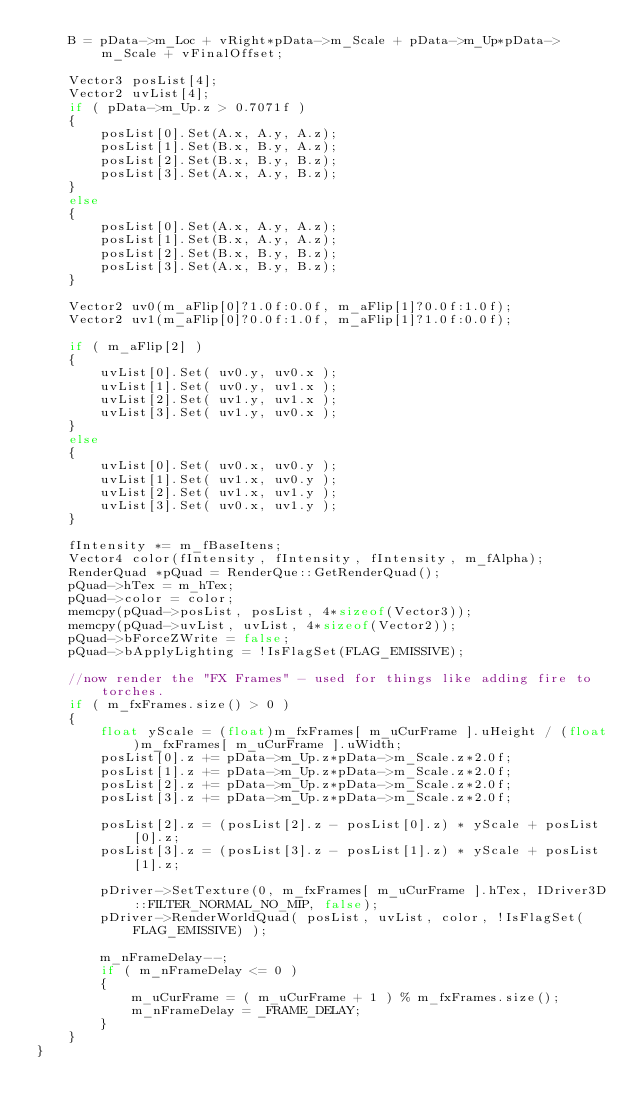Convert code to text. <code><loc_0><loc_0><loc_500><loc_500><_C++_>    B = pData->m_Loc + vRight*pData->m_Scale + pData->m_Up*pData->m_Scale + vFinalOffset;

    Vector3 posList[4];
    Vector2 uvList[4];
    if ( pData->m_Up.z > 0.7071f )
    {
        posList[0].Set(A.x, A.y, A.z);
        posList[1].Set(B.x, B.y, A.z);
        posList[2].Set(B.x, B.y, B.z);
        posList[3].Set(A.x, A.y, B.z);
    }
    else
    {
        posList[0].Set(A.x, A.y, A.z);
        posList[1].Set(B.x, A.y, A.z);
        posList[2].Set(B.x, B.y, B.z);
        posList[3].Set(A.x, B.y, B.z);
    }

    Vector2 uv0(m_aFlip[0]?1.0f:0.0f, m_aFlip[1]?0.0f:1.0f);
    Vector2 uv1(m_aFlip[0]?0.0f:1.0f, m_aFlip[1]?1.0f:0.0f);

    if ( m_aFlip[2] )
    {
        uvList[0].Set( uv0.y, uv0.x );
        uvList[1].Set( uv0.y, uv1.x );
        uvList[2].Set( uv1.y, uv1.x );
        uvList[3].Set( uv1.y, uv0.x );
    }
    else
    {
        uvList[0].Set( uv0.x, uv0.y );
        uvList[1].Set( uv1.x, uv0.y );
        uvList[2].Set( uv1.x, uv1.y );
        uvList[3].Set( uv0.x, uv1.y );
    }

    fIntensity *= m_fBaseItens;
    Vector4 color(fIntensity, fIntensity, fIntensity, m_fAlpha);
    RenderQuad *pQuad = RenderQue::GetRenderQuad();
    pQuad->hTex = m_hTex;
    pQuad->color = color;
    memcpy(pQuad->posList, posList, 4*sizeof(Vector3));
    memcpy(pQuad->uvList, uvList, 4*sizeof(Vector2));
    pQuad->bForceZWrite = false;
    pQuad->bApplyLighting = !IsFlagSet(FLAG_EMISSIVE);

    //now render the "FX Frames" - used for things like adding fire to torches.
    if ( m_fxFrames.size() > 0 )
    {
        float yScale = (float)m_fxFrames[ m_uCurFrame ].uHeight / (float)m_fxFrames[ m_uCurFrame ].uWidth;
        posList[0].z += pData->m_Up.z*pData->m_Scale.z*2.0f;
        posList[1].z += pData->m_Up.z*pData->m_Scale.z*2.0f;
        posList[2].z += pData->m_Up.z*pData->m_Scale.z*2.0f;
        posList[3].z += pData->m_Up.z*pData->m_Scale.z*2.0f;

        posList[2].z = (posList[2].z - posList[0].z) * yScale + posList[0].z;
        posList[3].z = (posList[3].z - posList[1].z) * yScale + posList[1].z;

        pDriver->SetTexture(0, m_fxFrames[ m_uCurFrame ].hTex, IDriver3D::FILTER_NORMAL_NO_MIP, false);
        pDriver->RenderWorldQuad( posList, uvList, color, !IsFlagSet(FLAG_EMISSIVE) );

        m_nFrameDelay--;
        if ( m_nFrameDelay <= 0 )
        {
            m_uCurFrame = ( m_uCurFrame + 1 ) % m_fxFrames.size();
            m_nFrameDelay = _FRAME_DELAY;
        }
    }
}
</code> 